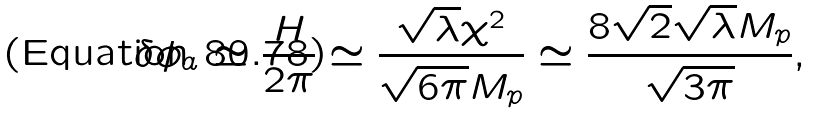<formula> <loc_0><loc_0><loc_500><loc_500>\delta \phi _ { a } \simeq \frac { H } { 2 \pi } \simeq \frac { \sqrt { \lambda } \chi ^ { 2 } } { \sqrt { 6 \pi } M _ { p } } \simeq \frac { 8 \sqrt { 2 } \sqrt { \lambda } M _ { p } } { \sqrt { 3 \pi } } ,</formula> 